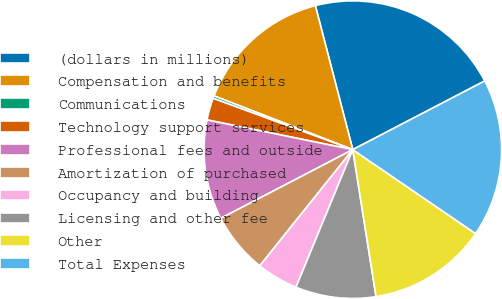<chart> <loc_0><loc_0><loc_500><loc_500><pie_chart><fcel>(dollars in millions)<fcel>Compensation and benefits<fcel>Communications<fcel>Technology support services<fcel>Professional fees and outside<fcel>Amortization of purchased<fcel>Occupancy and building<fcel>Licensing and other fee<fcel>Other<fcel>Total Expenses<nl><fcel>21.41%<fcel>15.07%<fcel>0.28%<fcel>2.4%<fcel>10.84%<fcel>6.62%<fcel>4.51%<fcel>8.73%<fcel>12.96%<fcel>17.18%<nl></chart> 